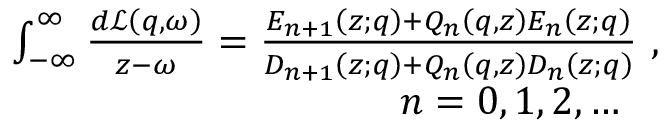Convert formula to latex. <formula><loc_0><loc_0><loc_500><loc_500>\begin{array} { r } { \int _ { - \infty } ^ { \infty } \frac { d \mathcal { L } \left ( q , \omega \right ) } { z - \omega } = \frac { E _ { n + 1 } \left ( z ; q \right ) + Q _ { n } \left ( q , z \right ) E _ { n } \left ( z ; q \right ) } { D _ { n + 1 } \left ( z ; q \right ) + Q _ { n } \left ( q , z \right ) D _ { n } \left ( z ; q \right ) } \ , } \\ { \quad n = 0 , 1 , 2 , \dots \quad } \end{array}</formula> 